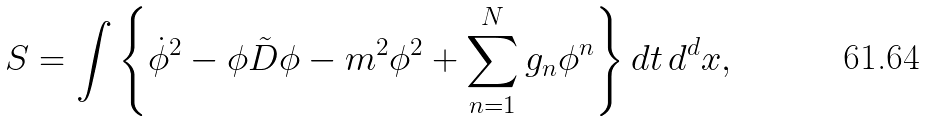<formula> <loc_0><loc_0><loc_500><loc_500>S = \int \left \{ \dot { \phi } ^ { 2 } - \phi \tilde { D } \phi - m ^ { 2 } \phi ^ { 2 } + \sum _ { n = 1 } ^ { N } g _ { n } \phi ^ { n } \right \} d t \, d ^ { d } x ,</formula> 